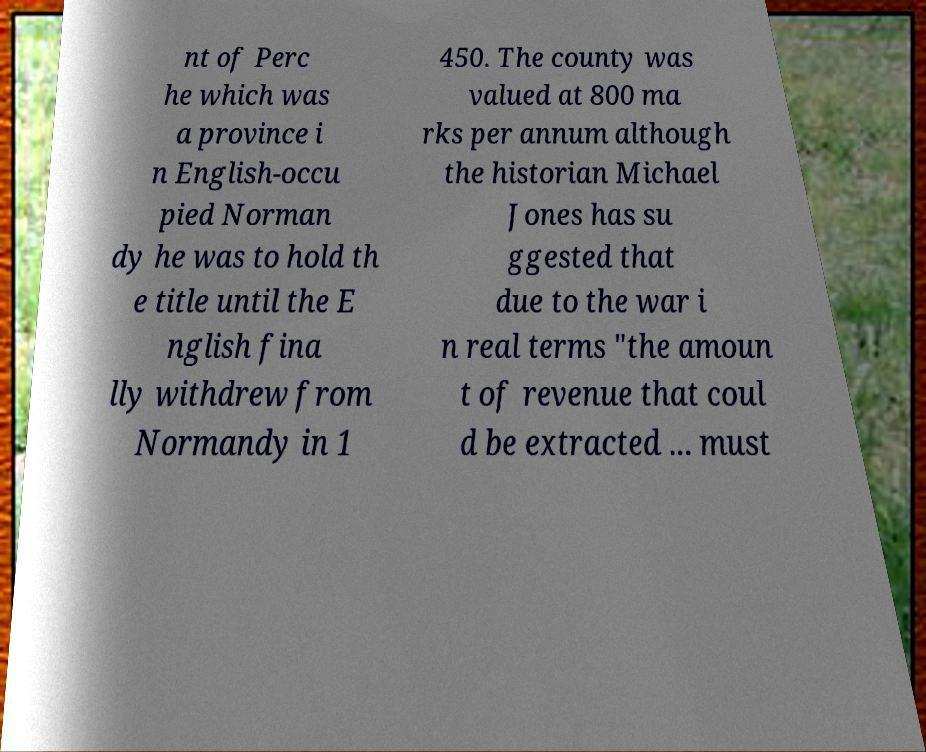I need the written content from this picture converted into text. Can you do that? nt of Perc he which was a province i n English-occu pied Norman dy he was to hold th e title until the E nglish fina lly withdrew from Normandy in 1 450. The county was valued at 800 ma rks per annum although the historian Michael Jones has su ggested that due to the war i n real terms "the amoun t of revenue that coul d be extracted ... must 